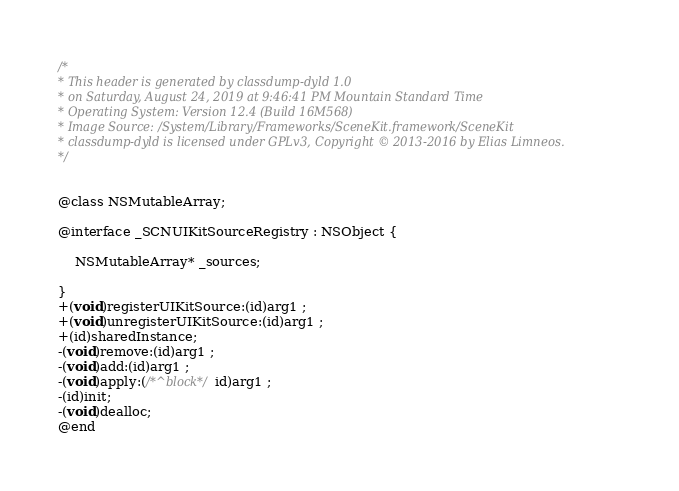<code> <loc_0><loc_0><loc_500><loc_500><_C_>/*
* This header is generated by classdump-dyld 1.0
* on Saturday, August 24, 2019 at 9:46:41 PM Mountain Standard Time
* Operating System: Version 12.4 (Build 16M568)
* Image Source: /System/Library/Frameworks/SceneKit.framework/SceneKit
* classdump-dyld is licensed under GPLv3, Copyright © 2013-2016 by Elias Limneos.
*/


@class NSMutableArray;

@interface _SCNUIKitSourceRegistry : NSObject {

	NSMutableArray* _sources;

}
+(void)registerUIKitSource:(id)arg1 ;
+(void)unregisterUIKitSource:(id)arg1 ;
+(id)sharedInstance;
-(void)remove:(id)arg1 ;
-(void)add:(id)arg1 ;
-(void)apply:(/*^block*/id)arg1 ;
-(id)init;
-(void)dealloc;
@end

</code> 